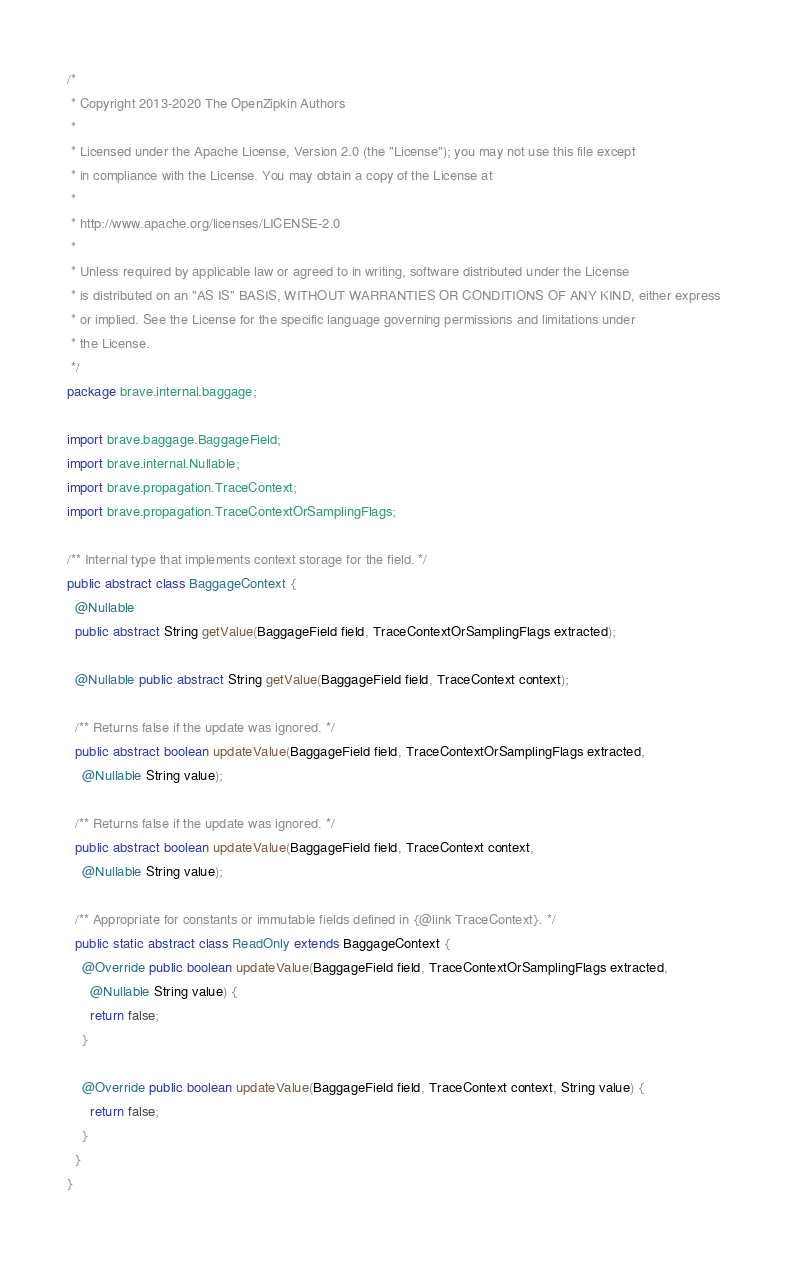<code> <loc_0><loc_0><loc_500><loc_500><_Java_>/*
 * Copyright 2013-2020 The OpenZipkin Authors
 *
 * Licensed under the Apache License, Version 2.0 (the "License"); you may not use this file except
 * in compliance with the License. You may obtain a copy of the License at
 *
 * http://www.apache.org/licenses/LICENSE-2.0
 *
 * Unless required by applicable law or agreed to in writing, software distributed under the License
 * is distributed on an "AS IS" BASIS, WITHOUT WARRANTIES OR CONDITIONS OF ANY KIND, either express
 * or implied. See the License for the specific language governing permissions and limitations under
 * the License.
 */
package brave.internal.baggage;

import brave.baggage.BaggageField;
import brave.internal.Nullable;
import brave.propagation.TraceContext;
import brave.propagation.TraceContextOrSamplingFlags;

/** Internal type that implements context storage for the field. */
public abstract class BaggageContext {
  @Nullable
  public abstract String getValue(BaggageField field, TraceContextOrSamplingFlags extracted);

  @Nullable public abstract String getValue(BaggageField field, TraceContext context);

  /** Returns false if the update was ignored. */
  public abstract boolean updateValue(BaggageField field, TraceContextOrSamplingFlags extracted,
    @Nullable String value);

  /** Returns false if the update was ignored. */
  public abstract boolean updateValue(BaggageField field, TraceContext context,
    @Nullable String value);

  /** Appropriate for constants or immutable fields defined in {@link TraceContext}. */
  public static abstract class ReadOnly extends BaggageContext {
    @Override public boolean updateValue(BaggageField field, TraceContextOrSamplingFlags extracted,
      @Nullable String value) {
      return false;
    }

    @Override public boolean updateValue(BaggageField field, TraceContext context, String value) {
      return false;
    }
  }
}
</code> 